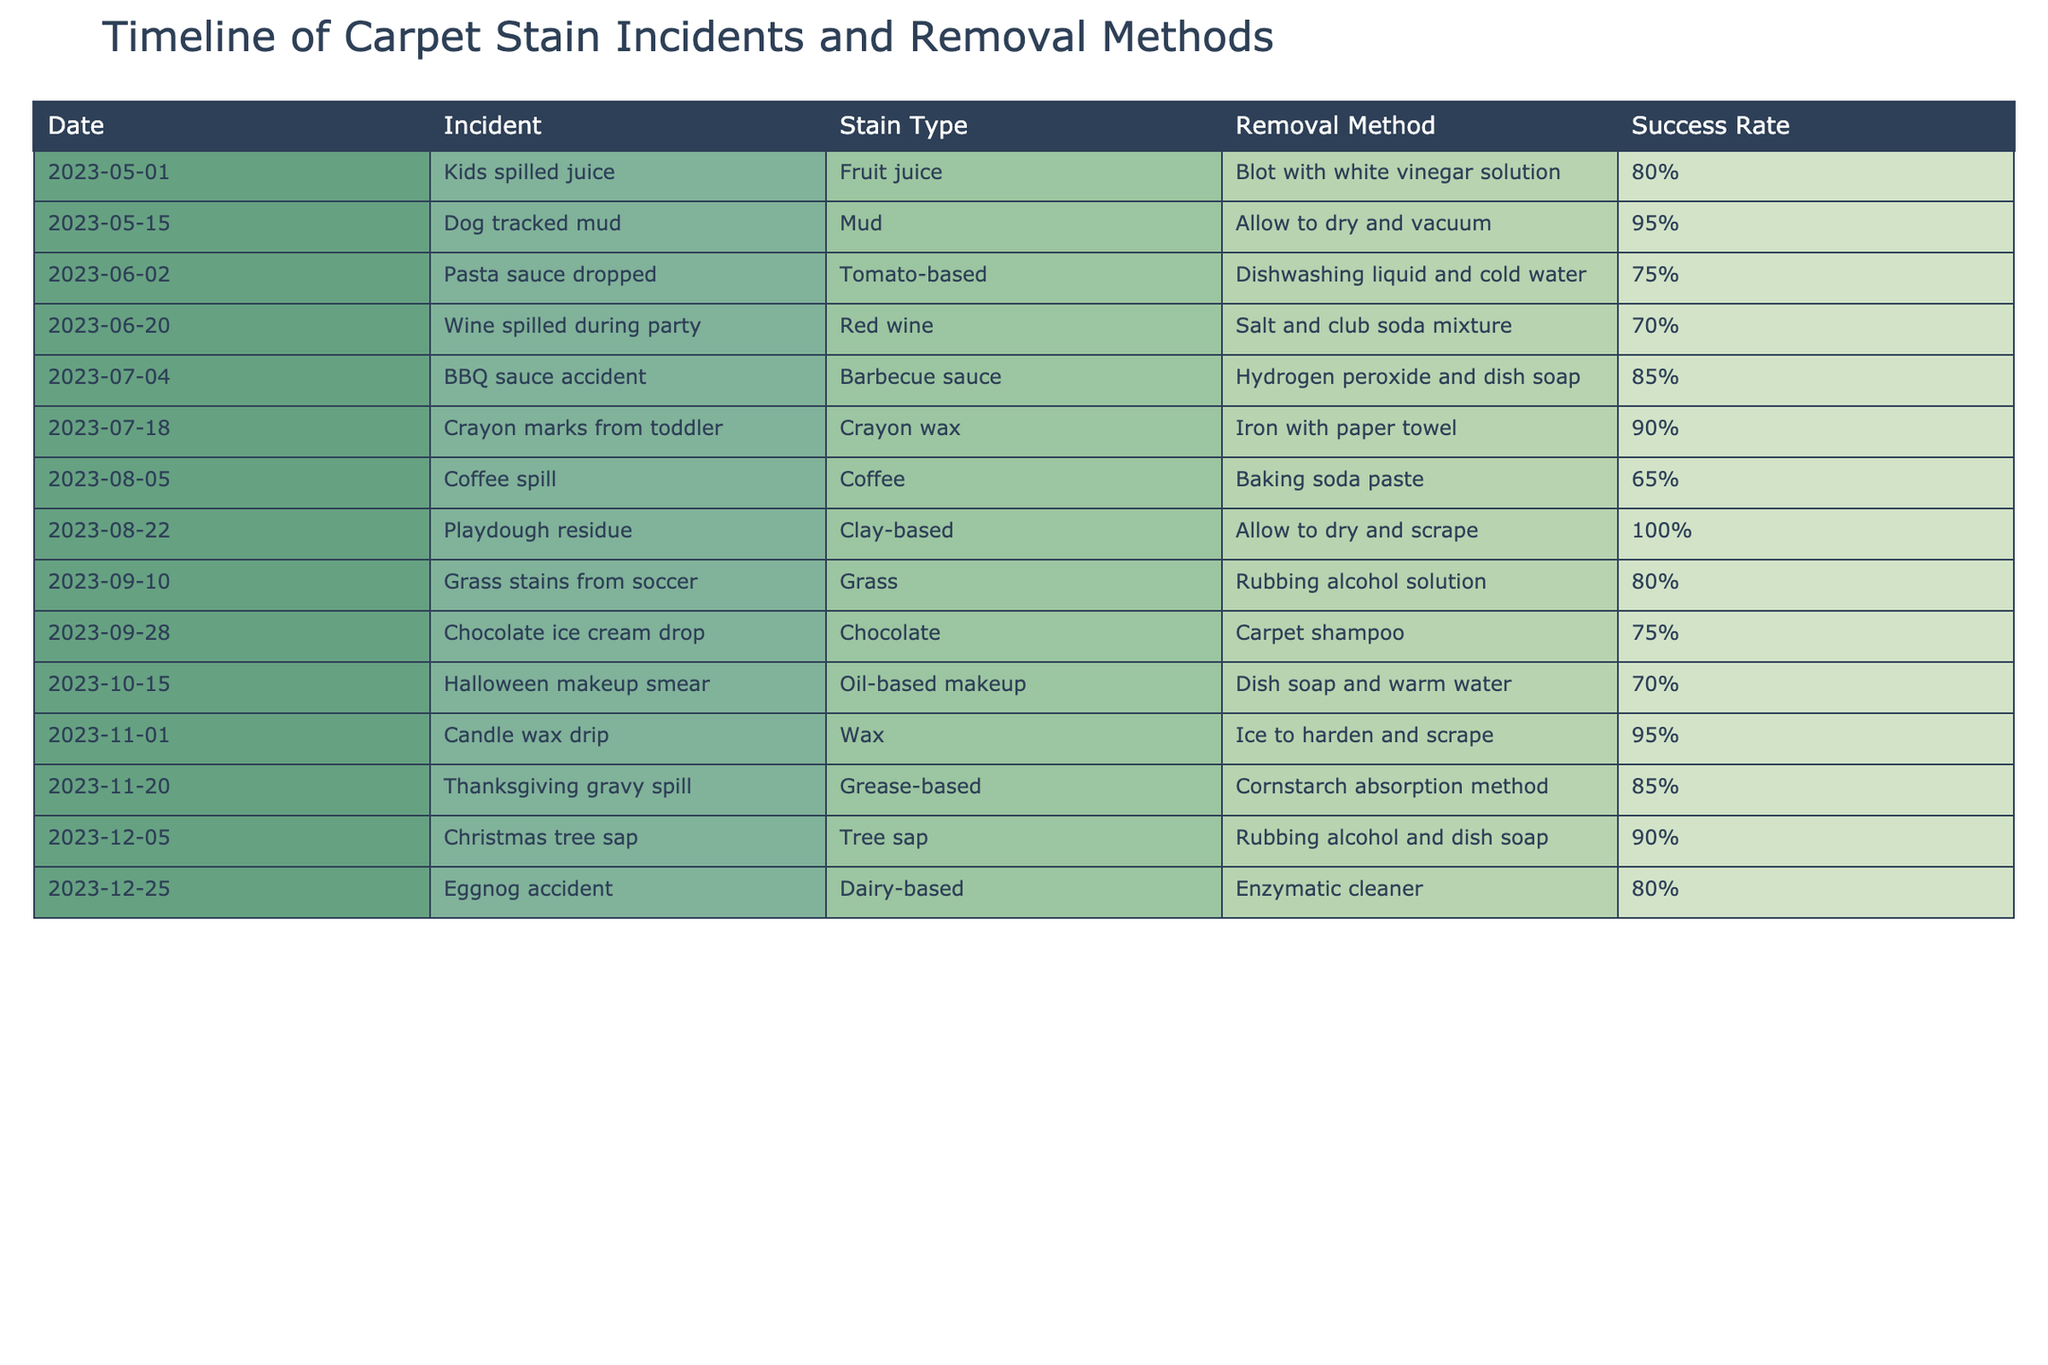What is the success rate for the removal method used for the red wine stain? The row corresponding to the red wine spill shows a success rate of 70% for the method used, which was salt and club soda mixture.
Answer: 70% Which stain type had the highest success rate for removal? Looking through the table, the stain type with the highest success rate is playdough residue, which had a 100% success rate with the method used.
Answer: Playdough residue On which date did the crayon marks incident occur? The crayon marks incident occurred on the date listed as July 18, 2023.
Answer: July 18, 2023 What are the two incidents that had a success rate of 80%? By scanning the success rates, there are two incidents with an 80% success rate: the fruit juice spill (May 1) and the soccer grass stains (September 10).
Answer: Fruit juice spill and soccer grass stains Is it true that all incidents involving animal involvement had a success rate of over 80%? There are two incidents related to animals: the dog tracking mud (95%) and the crayon marks from a toddler (not related to an animal). The dog incident had a successful method, proving the statement true for the dog but faulty since one incident had a rate lower than 80%.
Answer: No What is the average success rate for all incidents involving food stains? The food stains include fruit juice (80%), tomato-based sauce (75%), coffee (65%), barbecue sauce (85%), and dairy-based eggnog (80%). Adding these gives a total of 80 + 75 + 65 + 85 + 80 = 385. Dividing by 5 brings the average to 385/5 = 77%.
Answer: 77% Which removal method had a success rate below 70%, and how often did it occur? There are two methods with a success rate below 70%: the coffee spill (65%) with baking soda paste and the wine spill (70%) with the salt and club soda mixture. The coffee incident occurred once, while the wine incident occurred once as well.
Answer: Coffee spill (1 time) and wine spill (1 time) What is the total number of incidents where the removal method involved using a solution of some kind? Reviewing the table, the incidents involving a solution are the fruit juice (vinegar solution), grass (rubbing alcohol), and tree sap (rubbing alcohol and dish soap). Counting these, we find 3 incidents involved solutions.
Answer: 3 Was the candle wax incident successful? The success rate for the candle wax incident is listed as 95%, indicating a successful removal method.
Answer: Yes 